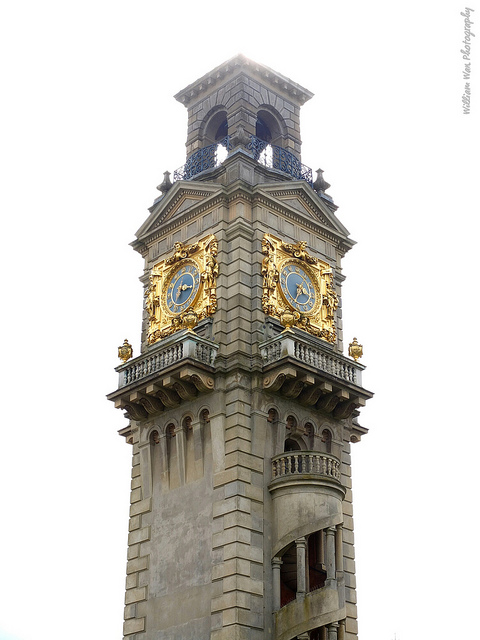<image>What are the gold objects on the clock? I don't know what the gold objects on the clock are. They can be designs, decoration, clock hands, frame, accents, or frame and hands. What are the gold objects on the clock? I am not sure what are the gold objects on the clock. It can be seen designs, decoration, clock hands, frame, or accents. 